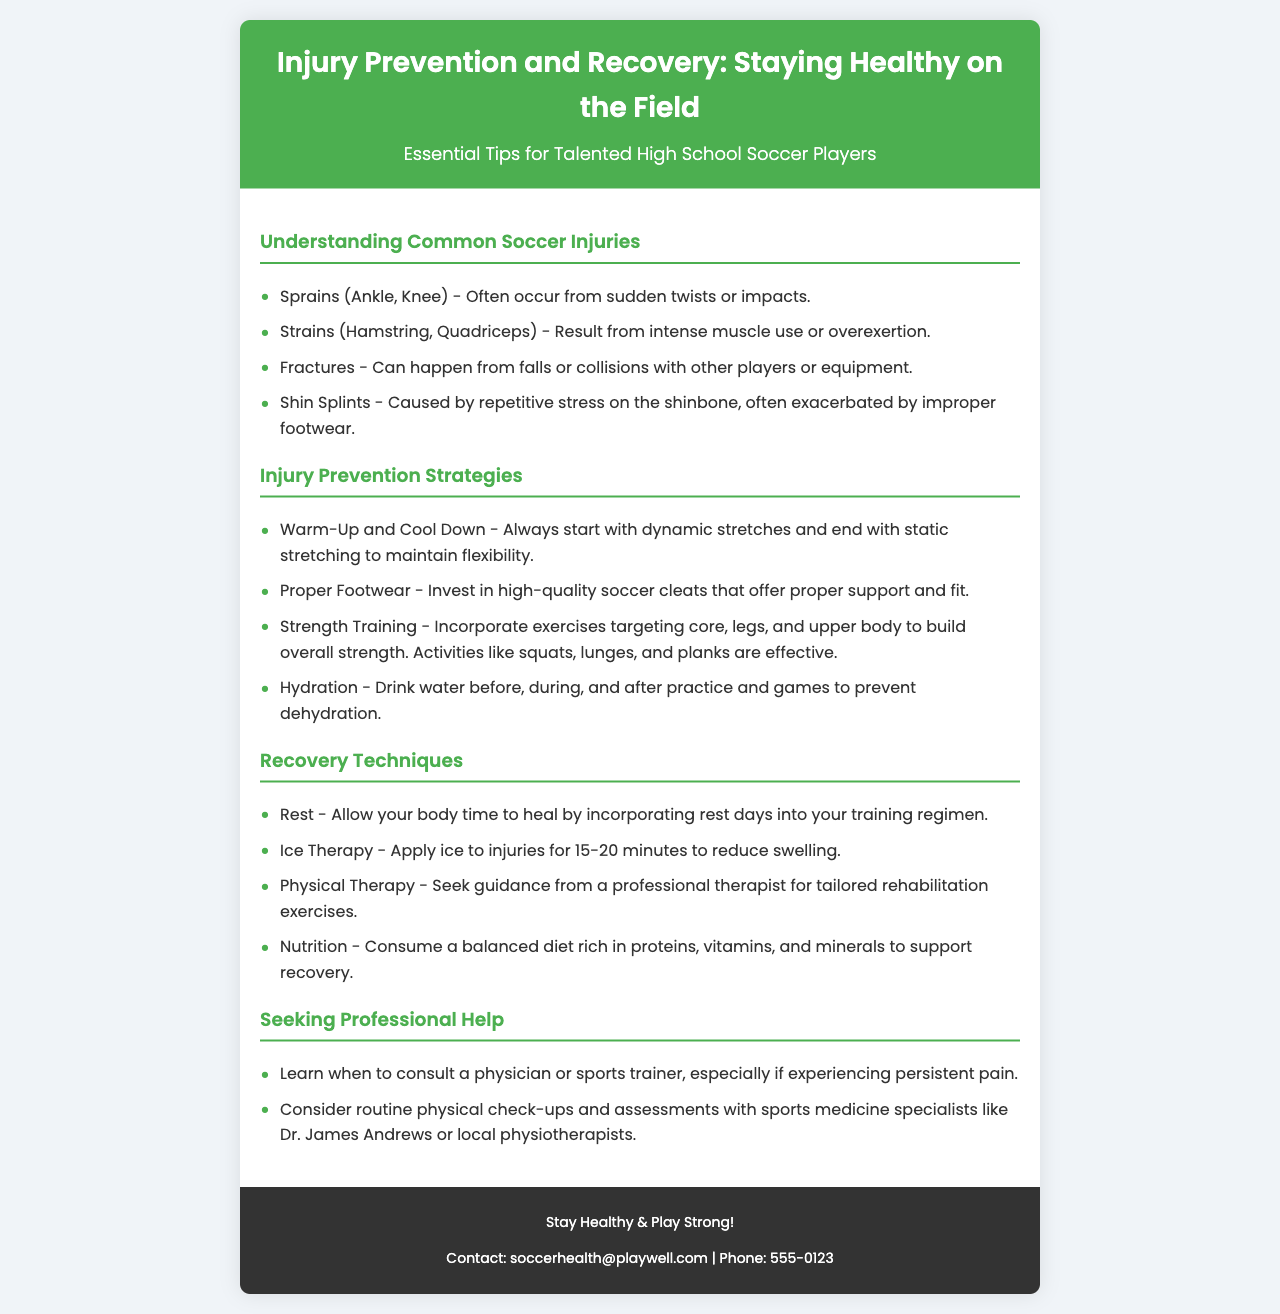What are some common soccer injuries? The common soccer injuries listed in the document are sprains, strains, fractures, and shin splints.
Answer: Sprains, strains, fractures, and shin splints What should you do to prevent dehydration? The document advises drinking water before, during, and after practice and games to prevent dehydration.
Answer: Drink water What is one effective strength training exercise mentioned? The document lists squats, lunges, and planks as effective strength training exercises.
Answer: Squats What is a recommended recovery technique? The document recommends allowing your body time to heal by incorporating rest days into your training regimen.
Answer: Rest When should you consult a physician or sports trainer? The document advises consulting a physician or sports trainer if experiencing persistent pain.
Answer: Persistent pain What type of therapy is suggested for injury recovery? Physical therapy is suggested for tailored rehabilitation exercises.
Answer: Physical therapy What is essential to include in a balanced diet for recovery? The document states that a balanced diet should be rich in proteins, vitamins, and minerals to support recovery.
Answer: Proteins, vitamins, and minerals What color is the header background of the brochure? The document describes the header background color as green.
Answer: Green 